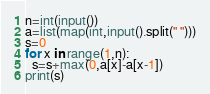Convert code to text. <code><loc_0><loc_0><loc_500><loc_500><_Python_>n=int(input())
a=list(map(int,input().split(" ")))
s=0
for x in range(1,n):
  s=s+max(0,a[x]-a[x-1])
print(s)</code> 